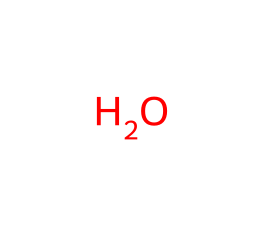how many atoms are in this chemical structure? The chemical structure represented by the SMILES is that of water, which consists of two hydrogen atoms and one oxygen atom. Counting the atoms gives a total of three atoms.
Answer: three what is the chemical name of this compound? The SMILES corresponds to the molecule known as water, which is commonly referred to by its chemical name dihydrogen monoxide.
Answer: water what is the molecular formula of this compound? The chemical structure with this SMILES corresponds to water, which has a molecular formula of H2O, showing it contains two hydrogen atoms and one oxygen atom.
Answer: H2O does this chemical exhibit coordination properties? Water is not a coordination compound by itself; it technically does not form coordination complexes without the presence of a metal ion. However, water can act as a ligand in coordination chemistry when bonded to a metal ion.
Answer: no how many hydrogen bonds can this compound form? Water molecules can participate in hydrogen bonding due to the presence of two hydrogen atoms for each water molecule, allowing each water molecule to form up to four hydrogen bonds with surrounding water molecules, though on average, each molecule forms about two or three bonds.
Answer: four what type of interaction dominates in this compound? In water, hydrogen bonding interactions are the most significant, arising from the polar nature of the molecule due to the high electronegativity of oxygen, which creates a partial positive charge on the hydrogen atoms and a partial negative charge on the oxygen atom.
Answer: hydrogen bonding what role does this compound play in Catholic rituals? Holy water, primarily composed of water, is used in Catholic rituals for blessings and purification, often symbolizing the Holy Spirit and cleansing from sin.
Answer: purification 